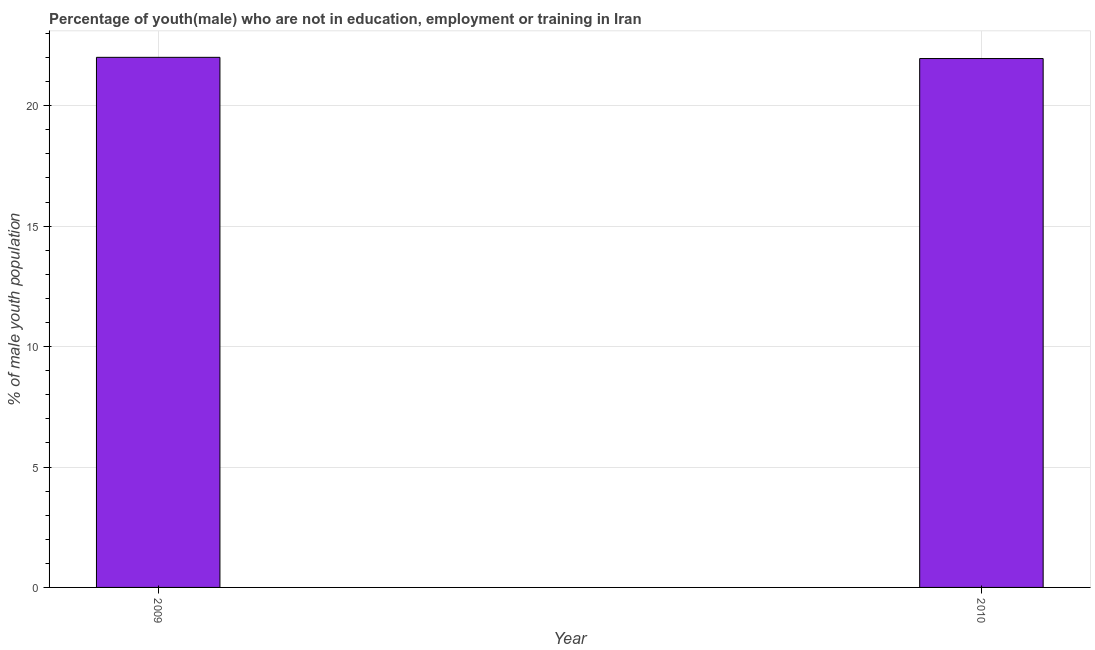Does the graph contain any zero values?
Give a very brief answer. No. What is the title of the graph?
Keep it short and to the point. Percentage of youth(male) who are not in education, employment or training in Iran. What is the label or title of the X-axis?
Provide a succinct answer. Year. What is the label or title of the Y-axis?
Your answer should be very brief. % of male youth population. What is the unemployed male youth population in 2009?
Offer a terse response. 22.01. Across all years, what is the maximum unemployed male youth population?
Your response must be concise. 22.01. Across all years, what is the minimum unemployed male youth population?
Your answer should be very brief. 21.96. What is the sum of the unemployed male youth population?
Offer a very short reply. 43.97. What is the average unemployed male youth population per year?
Keep it short and to the point. 21.98. What is the median unemployed male youth population?
Provide a short and direct response. 21.98. Is the unemployed male youth population in 2009 less than that in 2010?
Offer a very short reply. No. In how many years, is the unemployed male youth population greater than the average unemployed male youth population taken over all years?
Your response must be concise. 1. How many bars are there?
Ensure brevity in your answer.  2. What is the difference between two consecutive major ticks on the Y-axis?
Your answer should be compact. 5. What is the % of male youth population of 2009?
Provide a succinct answer. 22.01. What is the % of male youth population in 2010?
Ensure brevity in your answer.  21.96. What is the difference between the % of male youth population in 2009 and 2010?
Your response must be concise. 0.05. What is the ratio of the % of male youth population in 2009 to that in 2010?
Offer a very short reply. 1. 